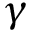Convert formula to latex. <formula><loc_0><loc_0><loc_500><loc_500>\gamma</formula> 